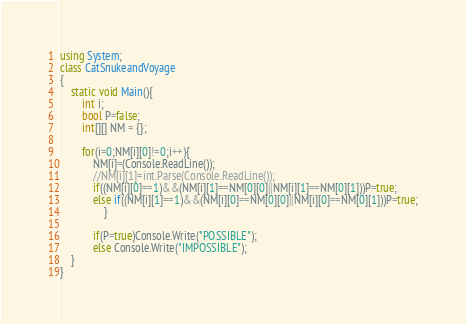Convert code to text. <code><loc_0><loc_0><loc_500><loc_500><_C#_>using System;
class CatSnukeandVoyage
{
	static void Main(){
		int i;
		bool P=false;
		int[][] NM = {};

		for(i=0;NM[i][0]!=0;i++){
			NM[i]=(Console.ReadLine());
			//NM[i][1]=int.Parse(Console.ReadLine());
			if((NM[i][0]==1)&&(NM[i][1]==NM[0][0]||NM[i][1]==NM[0][1]))P=true;
     	    else if((NM[i][1]==1)&&(NM[i][0]==NM[0][0]||NM[i][0]==NM[0][1]))P=true;
				}
      
			if(P=true)Console.Write("POSSIBLE");
			else Console.Write("IMPOSSIBLE");
	}
}</code> 